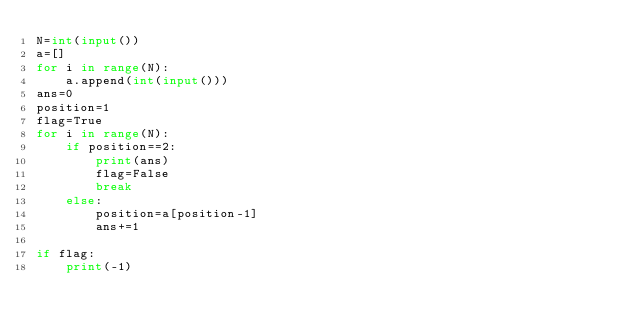Convert code to text. <code><loc_0><loc_0><loc_500><loc_500><_Python_>N=int(input())
a=[]
for i in range(N):
    a.append(int(input()))
ans=0
position=1
flag=True
for i in range(N):
    if position==2:
        print(ans)
        flag=False
        break 
    else:
        position=a[position-1]
        ans+=1

if flag:
    print(-1)</code> 